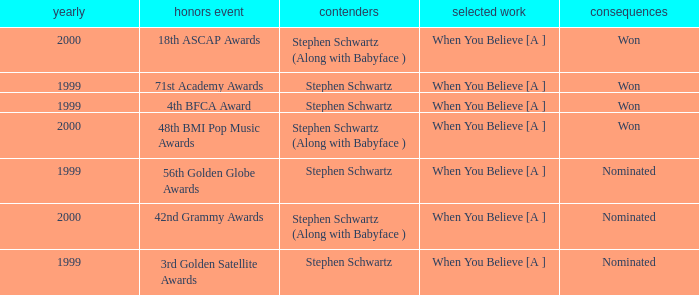What was the result in 2000? Won, Won, Nominated. 